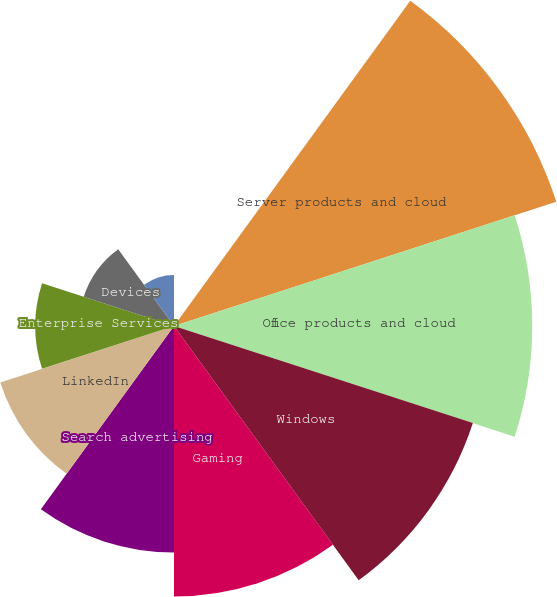Convert chart. <chart><loc_0><loc_0><loc_500><loc_500><pie_chart><fcel>Year Ended June 30<fcel>Server products and cloud<fcel>Office products and cloud<fcel>Windows<fcel>Gaming<fcel>Search advertising<fcel>LinkedIn<fcel>Enterprise Services<fcel>Devices<fcel>Other<nl><fcel>0.35%<fcel>19.65%<fcel>17.51%<fcel>15.36%<fcel>13.22%<fcel>11.07%<fcel>8.93%<fcel>6.78%<fcel>4.64%<fcel>2.49%<nl></chart> 